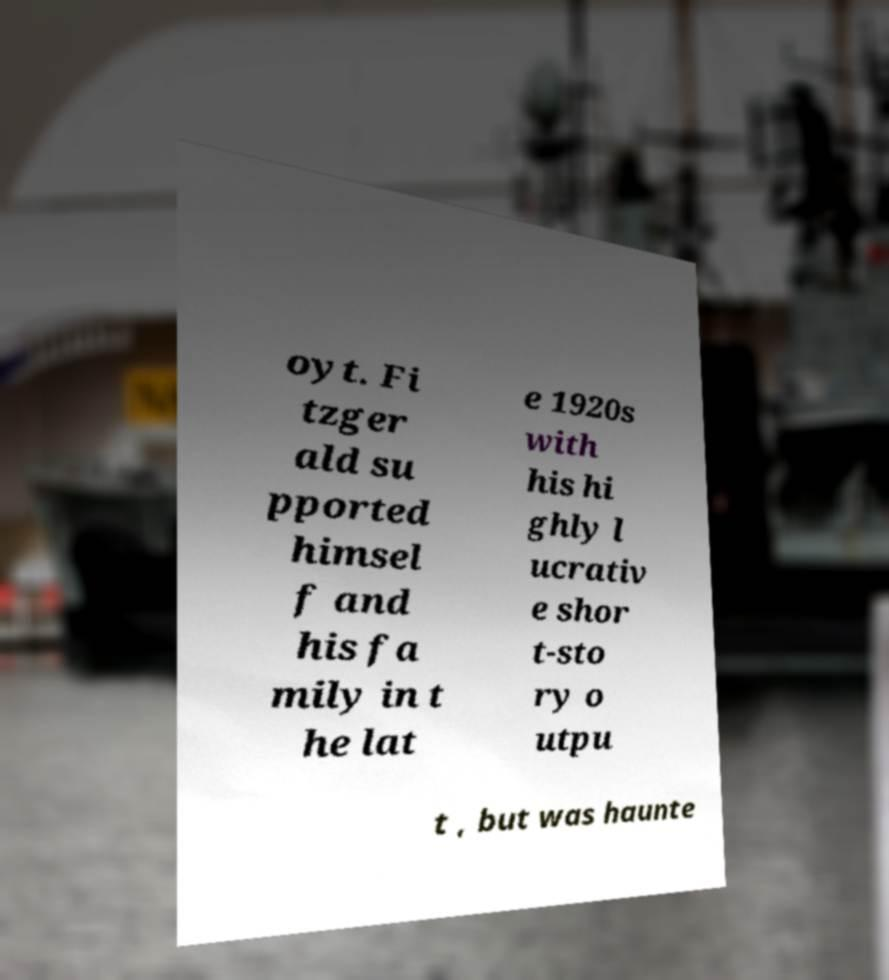Please identify and transcribe the text found in this image. oyt. Fi tzger ald su pported himsel f and his fa mily in t he lat e 1920s with his hi ghly l ucrativ e shor t-sto ry o utpu t , but was haunte 